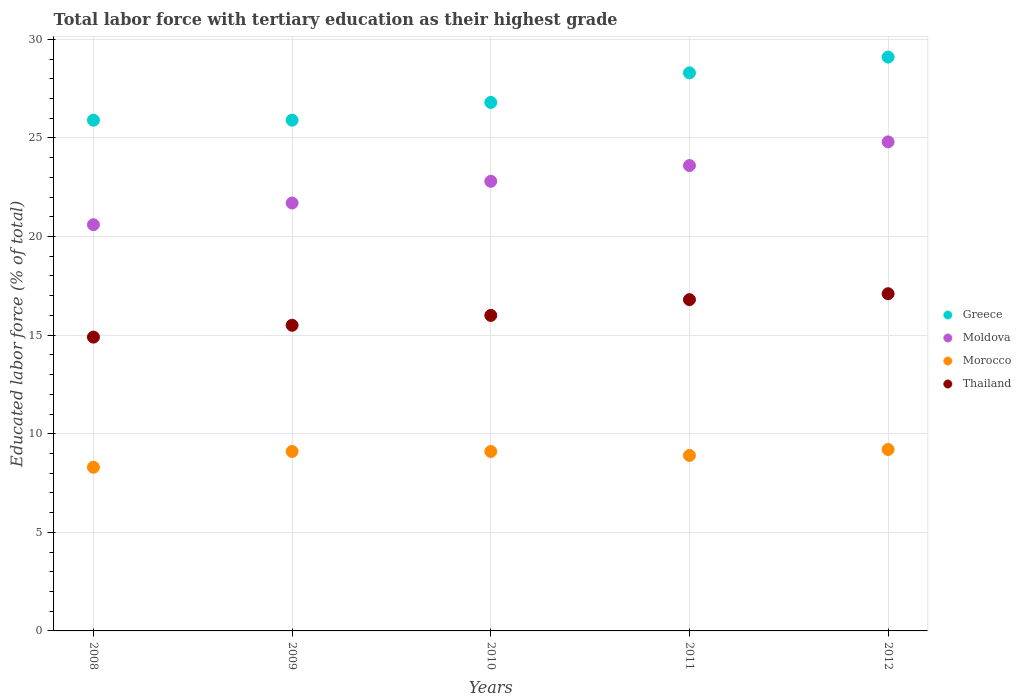How many different coloured dotlines are there?
Offer a very short reply. 4. What is the percentage of male labor force with tertiary education in Thailand in 2011?
Your answer should be compact. 16.8. Across all years, what is the maximum percentage of male labor force with tertiary education in Morocco?
Give a very brief answer. 9.2. Across all years, what is the minimum percentage of male labor force with tertiary education in Moldova?
Provide a succinct answer. 20.6. In which year was the percentage of male labor force with tertiary education in Morocco minimum?
Your response must be concise. 2008. What is the total percentage of male labor force with tertiary education in Thailand in the graph?
Provide a short and direct response. 80.3. What is the difference between the percentage of male labor force with tertiary education in Thailand in 2010 and that in 2011?
Give a very brief answer. -0.8. What is the average percentage of male labor force with tertiary education in Greece per year?
Ensure brevity in your answer.  27.2. In the year 2008, what is the difference between the percentage of male labor force with tertiary education in Morocco and percentage of male labor force with tertiary education in Greece?
Give a very brief answer. -17.6. In how many years, is the percentage of male labor force with tertiary education in Moldova greater than 16 %?
Your answer should be compact. 5. What is the ratio of the percentage of male labor force with tertiary education in Moldova in 2010 to that in 2012?
Give a very brief answer. 0.92. Is the percentage of male labor force with tertiary education in Morocco in 2010 less than that in 2011?
Your answer should be compact. No. What is the difference between the highest and the second highest percentage of male labor force with tertiary education in Greece?
Your answer should be very brief. 0.8. What is the difference between the highest and the lowest percentage of male labor force with tertiary education in Morocco?
Your answer should be compact. 0.9. Is the sum of the percentage of male labor force with tertiary education in Greece in 2008 and 2010 greater than the maximum percentage of male labor force with tertiary education in Thailand across all years?
Keep it short and to the point. Yes. Is it the case that in every year, the sum of the percentage of male labor force with tertiary education in Moldova and percentage of male labor force with tertiary education in Thailand  is greater than the sum of percentage of male labor force with tertiary education in Morocco and percentage of male labor force with tertiary education in Greece?
Make the answer very short. No. How many dotlines are there?
Keep it short and to the point. 4. What is the difference between two consecutive major ticks on the Y-axis?
Make the answer very short. 5. Are the values on the major ticks of Y-axis written in scientific E-notation?
Ensure brevity in your answer.  No. Does the graph contain any zero values?
Keep it short and to the point. No. Where does the legend appear in the graph?
Give a very brief answer. Center right. How many legend labels are there?
Your answer should be very brief. 4. What is the title of the graph?
Your answer should be compact. Total labor force with tertiary education as their highest grade. Does "Palau" appear as one of the legend labels in the graph?
Your response must be concise. No. What is the label or title of the Y-axis?
Your answer should be compact. Educated labor force (% of total). What is the Educated labor force (% of total) of Greece in 2008?
Provide a succinct answer. 25.9. What is the Educated labor force (% of total) in Moldova in 2008?
Give a very brief answer. 20.6. What is the Educated labor force (% of total) of Morocco in 2008?
Keep it short and to the point. 8.3. What is the Educated labor force (% of total) of Thailand in 2008?
Offer a very short reply. 14.9. What is the Educated labor force (% of total) of Greece in 2009?
Your answer should be compact. 25.9. What is the Educated labor force (% of total) in Moldova in 2009?
Make the answer very short. 21.7. What is the Educated labor force (% of total) in Morocco in 2009?
Give a very brief answer. 9.1. What is the Educated labor force (% of total) in Thailand in 2009?
Offer a terse response. 15.5. What is the Educated labor force (% of total) of Greece in 2010?
Your answer should be very brief. 26.8. What is the Educated labor force (% of total) in Moldova in 2010?
Give a very brief answer. 22.8. What is the Educated labor force (% of total) in Morocco in 2010?
Offer a terse response. 9.1. What is the Educated labor force (% of total) of Greece in 2011?
Give a very brief answer. 28.3. What is the Educated labor force (% of total) of Moldova in 2011?
Your response must be concise. 23.6. What is the Educated labor force (% of total) of Morocco in 2011?
Give a very brief answer. 8.9. What is the Educated labor force (% of total) in Thailand in 2011?
Your answer should be very brief. 16.8. What is the Educated labor force (% of total) in Greece in 2012?
Offer a terse response. 29.1. What is the Educated labor force (% of total) in Moldova in 2012?
Your answer should be very brief. 24.8. What is the Educated labor force (% of total) in Morocco in 2012?
Offer a very short reply. 9.2. What is the Educated labor force (% of total) in Thailand in 2012?
Your response must be concise. 17.1. Across all years, what is the maximum Educated labor force (% of total) of Greece?
Ensure brevity in your answer.  29.1. Across all years, what is the maximum Educated labor force (% of total) in Moldova?
Ensure brevity in your answer.  24.8. Across all years, what is the maximum Educated labor force (% of total) of Morocco?
Offer a very short reply. 9.2. Across all years, what is the maximum Educated labor force (% of total) in Thailand?
Provide a succinct answer. 17.1. Across all years, what is the minimum Educated labor force (% of total) of Greece?
Your answer should be very brief. 25.9. Across all years, what is the minimum Educated labor force (% of total) in Moldova?
Offer a very short reply. 20.6. Across all years, what is the minimum Educated labor force (% of total) in Morocco?
Your answer should be very brief. 8.3. Across all years, what is the minimum Educated labor force (% of total) of Thailand?
Your answer should be compact. 14.9. What is the total Educated labor force (% of total) in Greece in the graph?
Your answer should be very brief. 136. What is the total Educated labor force (% of total) of Moldova in the graph?
Give a very brief answer. 113.5. What is the total Educated labor force (% of total) in Morocco in the graph?
Make the answer very short. 44.6. What is the total Educated labor force (% of total) of Thailand in the graph?
Your answer should be very brief. 80.3. What is the difference between the Educated labor force (% of total) of Morocco in 2008 and that in 2009?
Offer a terse response. -0.8. What is the difference between the Educated labor force (% of total) of Thailand in 2008 and that in 2009?
Ensure brevity in your answer.  -0.6. What is the difference between the Educated labor force (% of total) in Greece in 2008 and that in 2010?
Your answer should be very brief. -0.9. What is the difference between the Educated labor force (% of total) of Thailand in 2008 and that in 2010?
Provide a short and direct response. -1.1. What is the difference between the Educated labor force (% of total) of Greece in 2008 and that in 2011?
Make the answer very short. -2.4. What is the difference between the Educated labor force (% of total) of Moldova in 2008 and that in 2011?
Offer a terse response. -3. What is the difference between the Educated labor force (% of total) of Morocco in 2008 and that in 2011?
Make the answer very short. -0.6. What is the difference between the Educated labor force (% of total) of Moldova in 2008 and that in 2012?
Offer a very short reply. -4.2. What is the difference between the Educated labor force (% of total) in Morocco in 2008 and that in 2012?
Your response must be concise. -0.9. What is the difference between the Educated labor force (% of total) of Thailand in 2008 and that in 2012?
Give a very brief answer. -2.2. What is the difference between the Educated labor force (% of total) of Greece in 2009 and that in 2010?
Your answer should be compact. -0.9. What is the difference between the Educated labor force (% of total) of Thailand in 2009 and that in 2010?
Keep it short and to the point. -0.5. What is the difference between the Educated labor force (% of total) in Moldova in 2009 and that in 2011?
Offer a very short reply. -1.9. What is the difference between the Educated labor force (% of total) of Morocco in 2009 and that in 2011?
Make the answer very short. 0.2. What is the difference between the Educated labor force (% of total) of Morocco in 2009 and that in 2012?
Ensure brevity in your answer.  -0.1. What is the difference between the Educated labor force (% of total) of Morocco in 2010 and that in 2011?
Your answer should be compact. 0.2. What is the difference between the Educated labor force (% of total) in Greece in 2010 and that in 2012?
Ensure brevity in your answer.  -2.3. What is the difference between the Educated labor force (% of total) in Moldova in 2010 and that in 2012?
Provide a succinct answer. -2. What is the difference between the Educated labor force (% of total) of Morocco in 2010 and that in 2012?
Give a very brief answer. -0.1. What is the difference between the Educated labor force (% of total) of Moldova in 2011 and that in 2012?
Ensure brevity in your answer.  -1.2. What is the difference between the Educated labor force (% of total) of Thailand in 2011 and that in 2012?
Offer a terse response. -0.3. What is the difference between the Educated labor force (% of total) of Greece in 2008 and the Educated labor force (% of total) of Moldova in 2009?
Give a very brief answer. 4.2. What is the difference between the Educated labor force (% of total) in Greece in 2008 and the Educated labor force (% of total) in Morocco in 2009?
Make the answer very short. 16.8. What is the difference between the Educated labor force (% of total) of Moldova in 2008 and the Educated labor force (% of total) of Morocco in 2009?
Offer a very short reply. 11.5. What is the difference between the Educated labor force (% of total) of Morocco in 2008 and the Educated labor force (% of total) of Thailand in 2009?
Keep it short and to the point. -7.2. What is the difference between the Educated labor force (% of total) in Greece in 2008 and the Educated labor force (% of total) in Moldova in 2010?
Make the answer very short. 3.1. What is the difference between the Educated labor force (% of total) of Greece in 2008 and the Educated labor force (% of total) of Morocco in 2010?
Keep it short and to the point. 16.8. What is the difference between the Educated labor force (% of total) of Moldova in 2008 and the Educated labor force (% of total) of Morocco in 2010?
Your response must be concise. 11.5. What is the difference between the Educated labor force (% of total) in Moldova in 2008 and the Educated labor force (% of total) in Thailand in 2010?
Provide a short and direct response. 4.6. What is the difference between the Educated labor force (% of total) in Morocco in 2008 and the Educated labor force (% of total) in Thailand in 2010?
Provide a succinct answer. -7.7. What is the difference between the Educated labor force (% of total) of Greece in 2008 and the Educated labor force (% of total) of Moldova in 2011?
Your answer should be very brief. 2.3. What is the difference between the Educated labor force (% of total) of Greece in 2008 and the Educated labor force (% of total) of Morocco in 2011?
Offer a very short reply. 17. What is the difference between the Educated labor force (% of total) in Greece in 2008 and the Educated labor force (% of total) in Thailand in 2011?
Keep it short and to the point. 9.1. What is the difference between the Educated labor force (% of total) in Greece in 2008 and the Educated labor force (% of total) in Morocco in 2012?
Offer a terse response. 16.7. What is the difference between the Educated labor force (% of total) in Greece in 2008 and the Educated labor force (% of total) in Thailand in 2012?
Offer a very short reply. 8.8. What is the difference between the Educated labor force (% of total) in Morocco in 2008 and the Educated labor force (% of total) in Thailand in 2012?
Your response must be concise. -8.8. What is the difference between the Educated labor force (% of total) of Greece in 2009 and the Educated labor force (% of total) of Moldova in 2010?
Keep it short and to the point. 3.1. What is the difference between the Educated labor force (% of total) of Greece in 2009 and the Educated labor force (% of total) of Thailand in 2010?
Provide a short and direct response. 9.9. What is the difference between the Educated labor force (% of total) of Moldova in 2009 and the Educated labor force (% of total) of Thailand in 2010?
Make the answer very short. 5.7. What is the difference between the Educated labor force (% of total) of Greece in 2009 and the Educated labor force (% of total) of Thailand in 2011?
Offer a terse response. 9.1. What is the difference between the Educated labor force (% of total) of Moldova in 2009 and the Educated labor force (% of total) of Morocco in 2011?
Provide a short and direct response. 12.8. What is the difference between the Educated labor force (% of total) of Moldova in 2009 and the Educated labor force (% of total) of Thailand in 2012?
Give a very brief answer. 4.6. What is the difference between the Educated labor force (% of total) of Morocco in 2009 and the Educated labor force (% of total) of Thailand in 2012?
Make the answer very short. -8. What is the difference between the Educated labor force (% of total) in Greece in 2010 and the Educated labor force (% of total) in Moldova in 2011?
Provide a succinct answer. 3.2. What is the difference between the Educated labor force (% of total) of Greece in 2010 and the Educated labor force (% of total) of Thailand in 2011?
Provide a succinct answer. 10. What is the difference between the Educated labor force (% of total) of Moldova in 2010 and the Educated labor force (% of total) of Thailand in 2011?
Make the answer very short. 6. What is the difference between the Educated labor force (% of total) in Morocco in 2010 and the Educated labor force (% of total) in Thailand in 2011?
Give a very brief answer. -7.7. What is the difference between the Educated labor force (% of total) in Greece in 2010 and the Educated labor force (% of total) in Moldova in 2012?
Offer a terse response. 2. What is the difference between the Educated labor force (% of total) of Greece in 2010 and the Educated labor force (% of total) of Morocco in 2012?
Keep it short and to the point. 17.6. What is the difference between the Educated labor force (% of total) in Greece in 2010 and the Educated labor force (% of total) in Thailand in 2012?
Offer a very short reply. 9.7. What is the difference between the Educated labor force (% of total) of Moldova in 2010 and the Educated labor force (% of total) of Morocco in 2012?
Keep it short and to the point. 13.6. What is the difference between the Educated labor force (% of total) of Moldova in 2010 and the Educated labor force (% of total) of Thailand in 2012?
Provide a short and direct response. 5.7. What is the difference between the Educated labor force (% of total) in Morocco in 2010 and the Educated labor force (% of total) in Thailand in 2012?
Offer a very short reply. -8. What is the difference between the Educated labor force (% of total) in Greece in 2011 and the Educated labor force (% of total) in Moldova in 2012?
Your answer should be very brief. 3.5. What is the difference between the Educated labor force (% of total) of Greece in 2011 and the Educated labor force (% of total) of Morocco in 2012?
Ensure brevity in your answer.  19.1. What is the difference between the Educated labor force (% of total) of Moldova in 2011 and the Educated labor force (% of total) of Morocco in 2012?
Your answer should be compact. 14.4. What is the difference between the Educated labor force (% of total) in Morocco in 2011 and the Educated labor force (% of total) in Thailand in 2012?
Your answer should be very brief. -8.2. What is the average Educated labor force (% of total) of Greece per year?
Your response must be concise. 27.2. What is the average Educated labor force (% of total) in Moldova per year?
Keep it short and to the point. 22.7. What is the average Educated labor force (% of total) in Morocco per year?
Keep it short and to the point. 8.92. What is the average Educated labor force (% of total) of Thailand per year?
Make the answer very short. 16.06. In the year 2008, what is the difference between the Educated labor force (% of total) in Greece and Educated labor force (% of total) in Morocco?
Make the answer very short. 17.6. In the year 2008, what is the difference between the Educated labor force (% of total) in Greece and Educated labor force (% of total) in Thailand?
Provide a short and direct response. 11. In the year 2008, what is the difference between the Educated labor force (% of total) in Moldova and Educated labor force (% of total) in Morocco?
Provide a short and direct response. 12.3. In the year 2008, what is the difference between the Educated labor force (% of total) of Moldova and Educated labor force (% of total) of Thailand?
Offer a very short reply. 5.7. In the year 2008, what is the difference between the Educated labor force (% of total) in Morocco and Educated labor force (% of total) in Thailand?
Give a very brief answer. -6.6. In the year 2009, what is the difference between the Educated labor force (% of total) in Greece and Educated labor force (% of total) in Thailand?
Your response must be concise. 10.4. In the year 2009, what is the difference between the Educated labor force (% of total) of Moldova and Educated labor force (% of total) of Morocco?
Your response must be concise. 12.6. In the year 2009, what is the difference between the Educated labor force (% of total) in Moldova and Educated labor force (% of total) in Thailand?
Provide a short and direct response. 6.2. In the year 2010, what is the difference between the Educated labor force (% of total) in Greece and Educated labor force (% of total) in Moldova?
Keep it short and to the point. 4. In the year 2010, what is the difference between the Educated labor force (% of total) of Greece and Educated labor force (% of total) of Morocco?
Your answer should be compact. 17.7. In the year 2010, what is the difference between the Educated labor force (% of total) of Greece and Educated labor force (% of total) of Thailand?
Provide a short and direct response. 10.8. In the year 2010, what is the difference between the Educated labor force (% of total) in Moldova and Educated labor force (% of total) in Morocco?
Keep it short and to the point. 13.7. In the year 2010, what is the difference between the Educated labor force (% of total) in Morocco and Educated labor force (% of total) in Thailand?
Your answer should be compact. -6.9. In the year 2011, what is the difference between the Educated labor force (% of total) of Greece and Educated labor force (% of total) of Moldova?
Offer a terse response. 4.7. In the year 2011, what is the difference between the Educated labor force (% of total) of Greece and Educated labor force (% of total) of Morocco?
Your response must be concise. 19.4. In the year 2011, what is the difference between the Educated labor force (% of total) of Greece and Educated labor force (% of total) of Thailand?
Offer a terse response. 11.5. In the year 2011, what is the difference between the Educated labor force (% of total) of Moldova and Educated labor force (% of total) of Thailand?
Ensure brevity in your answer.  6.8. In the year 2012, what is the difference between the Educated labor force (% of total) of Greece and Educated labor force (% of total) of Moldova?
Offer a very short reply. 4.3. In the year 2012, what is the difference between the Educated labor force (% of total) in Greece and Educated labor force (% of total) in Morocco?
Your answer should be very brief. 19.9. In the year 2012, what is the difference between the Educated labor force (% of total) in Moldova and Educated labor force (% of total) in Morocco?
Offer a very short reply. 15.6. In the year 2012, what is the difference between the Educated labor force (% of total) of Moldova and Educated labor force (% of total) of Thailand?
Provide a succinct answer. 7.7. In the year 2012, what is the difference between the Educated labor force (% of total) in Morocco and Educated labor force (% of total) in Thailand?
Keep it short and to the point. -7.9. What is the ratio of the Educated labor force (% of total) in Moldova in 2008 to that in 2009?
Offer a terse response. 0.95. What is the ratio of the Educated labor force (% of total) of Morocco in 2008 to that in 2009?
Provide a short and direct response. 0.91. What is the ratio of the Educated labor force (% of total) in Thailand in 2008 to that in 2009?
Make the answer very short. 0.96. What is the ratio of the Educated labor force (% of total) of Greece in 2008 to that in 2010?
Make the answer very short. 0.97. What is the ratio of the Educated labor force (% of total) of Moldova in 2008 to that in 2010?
Your answer should be compact. 0.9. What is the ratio of the Educated labor force (% of total) of Morocco in 2008 to that in 2010?
Your response must be concise. 0.91. What is the ratio of the Educated labor force (% of total) of Thailand in 2008 to that in 2010?
Your answer should be compact. 0.93. What is the ratio of the Educated labor force (% of total) of Greece in 2008 to that in 2011?
Your response must be concise. 0.92. What is the ratio of the Educated labor force (% of total) in Moldova in 2008 to that in 2011?
Provide a short and direct response. 0.87. What is the ratio of the Educated labor force (% of total) in Morocco in 2008 to that in 2011?
Offer a very short reply. 0.93. What is the ratio of the Educated labor force (% of total) of Thailand in 2008 to that in 2011?
Ensure brevity in your answer.  0.89. What is the ratio of the Educated labor force (% of total) in Greece in 2008 to that in 2012?
Your response must be concise. 0.89. What is the ratio of the Educated labor force (% of total) in Moldova in 2008 to that in 2012?
Your response must be concise. 0.83. What is the ratio of the Educated labor force (% of total) in Morocco in 2008 to that in 2012?
Provide a short and direct response. 0.9. What is the ratio of the Educated labor force (% of total) of Thailand in 2008 to that in 2012?
Offer a very short reply. 0.87. What is the ratio of the Educated labor force (% of total) of Greece in 2009 to that in 2010?
Provide a succinct answer. 0.97. What is the ratio of the Educated labor force (% of total) of Moldova in 2009 to that in 2010?
Your answer should be compact. 0.95. What is the ratio of the Educated labor force (% of total) of Thailand in 2009 to that in 2010?
Give a very brief answer. 0.97. What is the ratio of the Educated labor force (% of total) of Greece in 2009 to that in 2011?
Offer a terse response. 0.92. What is the ratio of the Educated labor force (% of total) in Moldova in 2009 to that in 2011?
Your answer should be compact. 0.92. What is the ratio of the Educated labor force (% of total) of Morocco in 2009 to that in 2011?
Your response must be concise. 1.02. What is the ratio of the Educated labor force (% of total) of Thailand in 2009 to that in 2011?
Offer a very short reply. 0.92. What is the ratio of the Educated labor force (% of total) in Greece in 2009 to that in 2012?
Offer a very short reply. 0.89. What is the ratio of the Educated labor force (% of total) in Morocco in 2009 to that in 2012?
Your response must be concise. 0.99. What is the ratio of the Educated labor force (% of total) of Thailand in 2009 to that in 2012?
Your response must be concise. 0.91. What is the ratio of the Educated labor force (% of total) in Greece in 2010 to that in 2011?
Provide a succinct answer. 0.95. What is the ratio of the Educated labor force (% of total) in Moldova in 2010 to that in 2011?
Your answer should be compact. 0.97. What is the ratio of the Educated labor force (% of total) in Morocco in 2010 to that in 2011?
Keep it short and to the point. 1.02. What is the ratio of the Educated labor force (% of total) in Thailand in 2010 to that in 2011?
Give a very brief answer. 0.95. What is the ratio of the Educated labor force (% of total) in Greece in 2010 to that in 2012?
Provide a short and direct response. 0.92. What is the ratio of the Educated labor force (% of total) in Moldova in 2010 to that in 2012?
Keep it short and to the point. 0.92. What is the ratio of the Educated labor force (% of total) in Morocco in 2010 to that in 2012?
Your answer should be compact. 0.99. What is the ratio of the Educated labor force (% of total) of Thailand in 2010 to that in 2012?
Give a very brief answer. 0.94. What is the ratio of the Educated labor force (% of total) in Greece in 2011 to that in 2012?
Your answer should be very brief. 0.97. What is the ratio of the Educated labor force (% of total) in Moldova in 2011 to that in 2012?
Ensure brevity in your answer.  0.95. What is the ratio of the Educated labor force (% of total) in Morocco in 2011 to that in 2012?
Your answer should be very brief. 0.97. What is the ratio of the Educated labor force (% of total) in Thailand in 2011 to that in 2012?
Your answer should be very brief. 0.98. What is the difference between the highest and the second highest Educated labor force (% of total) of Greece?
Ensure brevity in your answer.  0.8. What is the difference between the highest and the second highest Educated labor force (% of total) in Thailand?
Offer a very short reply. 0.3. What is the difference between the highest and the lowest Educated labor force (% of total) in Moldova?
Your answer should be compact. 4.2. What is the difference between the highest and the lowest Educated labor force (% of total) in Morocco?
Make the answer very short. 0.9. 